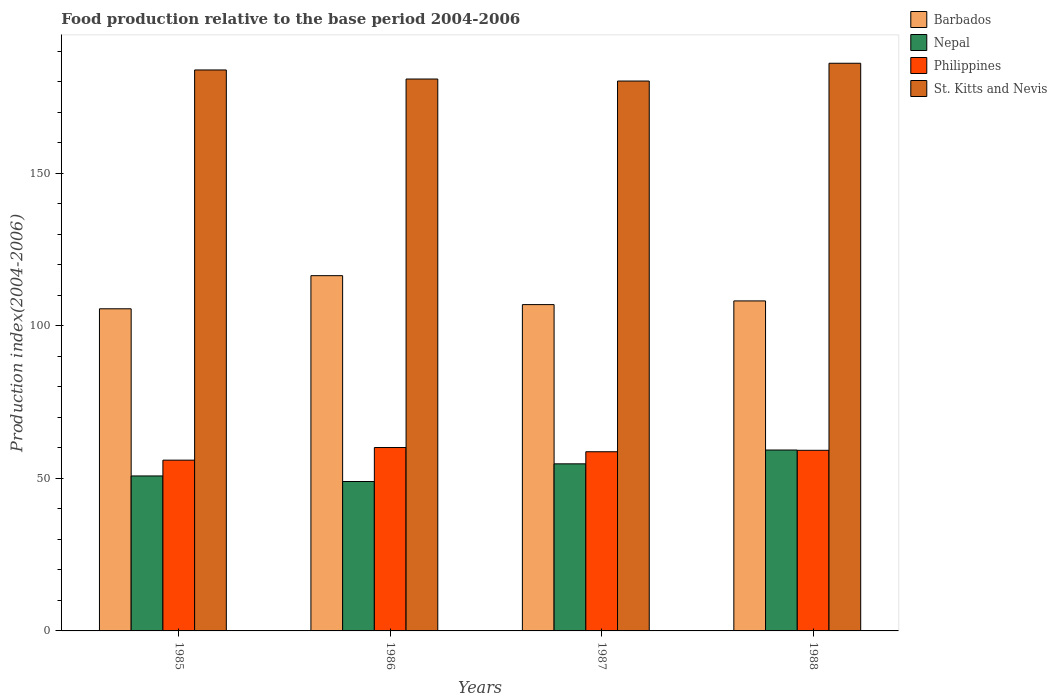How many groups of bars are there?
Provide a short and direct response. 4. Are the number of bars on each tick of the X-axis equal?
Ensure brevity in your answer.  Yes. How many bars are there on the 2nd tick from the right?
Your answer should be very brief. 4. What is the label of the 3rd group of bars from the left?
Your response must be concise. 1987. What is the food production index in Philippines in 1985?
Your response must be concise. 55.99. Across all years, what is the maximum food production index in Philippines?
Keep it short and to the point. 60.13. Across all years, what is the minimum food production index in St. Kitts and Nevis?
Your response must be concise. 180.29. In which year was the food production index in St. Kitts and Nevis maximum?
Offer a terse response. 1988. In which year was the food production index in Barbados minimum?
Ensure brevity in your answer.  1985. What is the total food production index in Philippines in the graph?
Give a very brief answer. 234.09. What is the difference between the food production index in Philippines in 1985 and that in 1987?
Give a very brief answer. -2.76. What is the difference between the food production index in Philippines in 1986 and the food production index in Barbados in 1987?
Your response must be concise. -46.86. What is the average food production index in Nepal per year?
Offer a very short reply. 53.47. In the year 1986, what is the difference between the food production index in Philippines and food production index in Nepal?
Provide a short and direct response. 11.14. What is the ratio of the food production index in St. Kitts and Nevis in 1986 to that in 1988?
Your answer should be very brief. 0.97. What is the difference between the highest and the second highest food production index in Barbados?
Offer a very short reply. 8.28. What is the difference between the highest and the lowest food production index in Barbados?
Ensure brevity in your answer.  10.86. Is the sum of the food production index in Philippines in 1985 and 1986 greater than the maximum food production index in Barbados across all years?
Ensure brevity in your answer.  No. What does the 2nd bar from the left in 1985 represents?
Your answer should be very brief. Nepal. What does the 3rd bar from the right in 1985 represents?
Provide a succinct answer. Nepal. Is it the case that in every year, the sum of the food production index in Nepal and food production index in St. Kitts and Nevis is greater than the food production index in Philippines?
Keep it short and to the point. Yes. Are all the bars in the graph horizontal?
Your response must be concise. No. How many years are there in the graph?
Offer a terse response. 4. What is the difference between two consecutive major ticks on the Y-axis?
Your answer should be compact. 50. Are the values on the major ticks of Y-axis written in scientific E-notation?
Your response must be concise. No. Does the graph contain grids?
Your answer should be compact. No. Where does the legend appear in the graph?
Give a very brief answer. Top right. How many legend labels are there?
Your answer should be very brief. 4. What is the title of the graph?
Provide a succinct answer. Food production relative to the base period 2004-2006. What is the label or title of the Y-axis?
Make the answer very short. Production index(2004-2006). What is the Production index(2004-2006) of Barbados in 1985?
Keep it short and to the point. 105.62. What is the Production index(2004-2006) in Nepal in 1985?
Your response must be concise. 50.81. What is the Production index(2004-2006) in Philippines in 1985?
Make the answer very short. 55.99. What is the Production index(2004-2006) of St. Kitts and Nevis in 1985?
Your answer should be compact. 183.92. What is the Production index(2004-2006) of Barbados in 1986?
Your response must be concise. 116.48. What is the Production index(2004-2006) in Nepal in 1986?
Make the answer very short. 48.99. What is the Production index(2004-2006) of Philippines in 1986?
Your response must be concise. 60.13. What is the Production index(2004-2006) in St. Kitts and Nevis in 1986?
Offer a very short reply. 180.95. What is the Production index(2004-2006) of Barbados in 1987?
Your answer should be very brief. 106.99. What is the Production index(2004-2006) of Nepal in 1987?
Your answer should be compact. 54.78. What is the Production index(2004-2006) of Philippines in 1987?
Make the answer very short. 58.75. What is the Production index(2004-2006) in St. Kitts and Nevis in 1987?
Keep it short and to the point. 180.29. What is the Production index(2004-2006) of Barbados in 1988?
Make the answer very short. 108.2. What is the Production index(2004-2006) of Nepal in 1988?
Offer a very short reply. 59.31. What is the Production index(2004-2006) of Philippines in 1988?
Your response must be concise. 59.22. What is the Production index(2004-2006) in St. Kitts and Nevis in 1988?
Offer a very short reply. 186.12. Across all years, what is the maximum Production index(2004-2006) of Barbados?
Ensure brevity in your answer.  116.48. Across all years, what is the maximum Production index(2004-2006) of Nepal?
Provide a succinct answer. 59.31. Across all years, what is the maximum Production index(2004-2006) in Philippines?
Offer a very short reply. 60.13. Across all years, what is the maximum Production index(2004-2006) in St. Kitts and Nevis?
Your answer should be very brief. 186.12. Across all years, what is the minimum Production index(2004-2006) in Barbados?
Offer a very short reply. 105.62. Across all years, what is the minimum Production index(2004-2006) of Nepal?
Ensure brevity in your answer.  48.99. Across all years, what is the minimum Production index(2004-2006) in Philippines?
Make the answer very short. 55.99. Across all years, what is the minimum Production index(2004-2006) in St. Kitts and Nevis?
Make the answer very short. 180.29. What is the total Production index(2004-2006) in Barbados in the graph?
Ensure brevity in your answer.  437.29. What is the total Production index(2004-2006) in Nepal in the graph?
Provide a succinct answer. 213.89. What is the total Production index(2004-2006) in Philippines in the graph?
Offer a terse response. 234.09. What is the total Production index(2004-2006) in St. Kitts and Nevis in the graph?
Your answer should be very brief. 731.28. What is the difference between the Production index(2004-2006) of Barbados in 1985 and that in 1986?
Offer a terse response. -10.86. What is the difference between the Production index(2004-2006) of Nepal in 1985 and that in 1986?
Offer a terse response. 1.82. What is the difference between the Production index(2004-2006) in Philippines in 1985 and that in 1986?
Offer a terse response. -4.14. What is the difference between the Production index(2004-2006) of St. Kitts and Nevis in 1985 and that in 1986?
Offer a very short reply. 2.97. What is the difference between the Production index(2004-2006) in Barbados in 1985 and that in 1987?
Give a very brief answer. -1.37. What is the difference between the Production index(2004-2006) of Nepal in 1985 and that in 1987?
Offer a very short reply. -3.97. What is the difference between the Production index(2004-2006) of Philippines in 1985 and that in 1987?
Make the answer very short. -2.76. What is the difference between the Production index(2004-2006) of St. Kitts and Nevis in 1985 and that in 1987?
Your answer should be very brief. 3.63. What is the difference between the Production index(2004-2006) in Barbados in 1985 and that in 1988?
Give a very brief answer. -2.58. What is the difference between the Production index(2004-2006) in Philippines in 1985 and that in 1988?
Your answer should be compact. -3.23. What is the difference between the Production index(2004-2006) of St. Kitts and Nevis in 1985 and that in 1988?
Make the answer very short. -2.2. What is the difference between the Production index(2004-2006) in Barbados in 1986 and that in 1987?
Your response must be concise. 9.49. What is the difference between the Production index(2004-2006) of Nepal in 1986 and that in 1987?
Offer a terse response. -5.79. What is the difference between the Production index(2004-2006) in Philippines in 1986 and that in 1987?
Provide a succinct answer. 1.38. What is the difference between the Production index(2004-2006) of St. Kitts and Nevis in 1986 and that in 1987?
Your answer should be very brief. 0.66. What is the difference between the Production index(2004-2006) in Barbados in 1986 and that in 1988?
Offer a terse response. 8.28. What is the difference between the Production index(2004-2006) of Nepal in 1986 and that in 1988?
Your answer should be very brief. -10.32. What is the difference between the Production index(2004-2006) in Philippines in 1986 and that in 1988?
Offer a very short reply. 0.91. What is the difference between the Production index(2004-2006) of St. Kitts and Nevis in 1986 and that in 1988?
Offer a very short reply. -5.17. What is the difference between the Production index(2004-2006) in Barbados in 1987 and that in 1988?
Offer a very short reply. -1.21. What is the difference between the Production index(2004-2006) in Nepal in 1987 and that in 1988?
Make the answer very short. -4.53. What is the difference between the Production index(2004-2006) in Philippines in 1987 and that in 1988?
Offer a very short reply. -0.47. What is the difference between the Production index(2004-2006) in St. Kitts and Nevis in 1987 and that in 1988?
Your response must be concise. -5.83. What is the difference between the Production index(2004-2006) in Barbados in 1985 and the Production index(2004-2006) in Nepal in 1986?
Keep it short and to the point. 56.63. What is the difference between the Production index(2004-2006) in Barbados in 1985 and the Production index(2004-2006) in Philippines in 1986?
Offer a very short reply. 45.49. What is the difference between the Production index(2004-2006) of Barbados in 1985 and the Production index(2004-2006) of St. Kitts and Nevis in 1986?
Ensure brevity in your answer.  -75.33. What is the difference between the Production index(2004-2006) of Nepal in 1985 and the Production index(2004-2006) of Philippines in 1986?
Your answer should be compact. -9.32. What is the difference between the Production index(2004-2006) in Nepal in 1985 and the Production index(2004-2006) in St. Kitts and Nevis in 1986?
Your answer should be very brief. -130.14. What is the difference between the Production index(2004-2006) in Philippines in 1985 and the Production index(2004-2006) in St. Kitts and Nevis in 1986?
Keep it short and to the point. -124.96. What is the difference between the Production index(2004-2006) of Barbados in 1985 and the Production index(2004-2006) of Nepal in 1987?
Provide a short and direct response. 50.84. What is the difference between the Production index(2004-2006) of Barbados in 1985 and the Production index(2004-2006) of Philippines in 1987?
Your answer should be compact. 46.87. What is the difference between the Production index(2004-2006) in Barbados in 1985 and the Production index(2004-2006) in St. Kitts and Nevis in 1987?
Keep it short and to the point. -74.67. What is the difference between the Production index(2004-2006) in Nepal in 1985 and the Production index(2004-2006) in Philippines in 1987?
Make the answer very short. -7.94. What is the difference between the Production index(2004-2006) in Nepal in 1985 and the Production index(2004-2006) in St. Kitts and Nevis in 1987?
Your answer should be compact. -129.48. What is the difference between the Production index(2004-2006) in Philippines in 1985 and the Production index(2004-2006) in St. Kitts and Nevis in 1987?
Your answer should be very brief. -124.3. What is the difference between the Production index(2004-2006) of Barbados in 1985 and the Production index(2004-2006) of Nepal in 1988?
Offer a very short reply. 46.31. What is the difference between the Production index(2004-2006) of Barbados in 1985 and the Production index(2004-2006) of Philippines in 1988?
Offer a very short reply. 46.4. What is the difference between the Production index(2004-2006) of Barbados in 1985 and the Production index(2004-2006) of St. Kitts and Nevis in 1988?
Your answer should be very brief. -80.5. What is the difference between the Production index(2004-2006) in Nepal in 1985 and the Production index(2004-2006) in Philippines in 1988?
Offer a terse response. -8.41. What is the difference between the Production index(2004-2006) in Nepal in 1985 and the Production index(2004-2006) in St. Kitts and Nevis in 1988?
Ensure brevity in your answer.  -135.31. What is the difference between the Production index(2004-2006) of Philippines in 1985 and the Production index(2004-2006) of St. Kitts and Nevis in 1988?
Your answer should be very brief. -130.13. What is the difference between the Production index(2004-2006) of Barbados in 1986 and the Production index(2004-2006) of Nepal in 1987?
Offer a very short reply. 61.7. What is the difference between the Production index(2004-2006) of Barbados in 1986 and the Production index(2004-2006) of Philippines in 1987?
Your answer should be very brief. 57.73. What is the difference between the Production index(2004-2006) in Barbados in 1986 and the Production index(2004-2006) in St. Kitts and Nevis in 1987?
Your response must be concise. -63.81. What is the difference between the Production index(2004-2006) in Nepal in 1986 and the Production index(2004-2006) in Philippines in 1987?
Keep it short and to the point. -9.76. What is the difference between the Production index(2004-2006) in Nepal in 1986 and the Production index(2004-2006) in St. Kitts and Nevis in 1987?
Offer a very short reply. -131.3. What is the difference between the Production index(2004-2006) of Philippines in 1986 and the Production index(2004-2006) of St. Kitts and Nevis in 1987?
Your response must be concise. -120.16. What is the difference between the Production index(2004-2006) of Barbados in 1986 and the Production index(2004-2006) of Nepal in 1988?
Ensure brevity in your answer.  57.17. What is the difference between the Production index(2004-2006) in Barbados in 1986 and the Production index(2004-2006) in Philippines in 1988?
Offer a very short reply. 57.26. What is the difference between the Production index(2004-2006) of Barbados in 1986 and the Production index(2004-2006) of St. Kitts and Nevis in 1988?
Offer a terse response. -69.64. What is the difference between the Production index(2004-2006) in Nepal in 1986 and the Production index(2004-2006) in Philippines in 1988?
Offer a terse response. -10.23. What is the difference between the Production index(2004-2006) in Nepal in 1986 and the Production index(2004-2006) in St. Kitts and Nevis in 1988?
Provide a succinct answer. -137.13. What is the difference between the Production index(2004-2006) in Philippines in 1986 and the Production index(2004-2006) in St. Kitts and Nevis in 1988?
Ensure brevity in your answer.  -125.99. What is the difference between the Production index(2004-2006) of Barbados in 1987 and the Production index(2004-2006) of Nepal in 1988?
Your response must be concise. 47.68. What is the difference between the Production index(2004-2006) in Barbados in 1987 and the Production index(2004-2006) in Philippines in 1988?
Offer a terse response. 47.77. What is the difference between the Production index(2004-2006) of Barbados in 1987 and the Production index(2004-2006) of St. Kitts and Nevis in 1988?
Keep it short and to the point. -79.13. What is the difference between the Production index(2004-2006) in Nepal in 1987 and the Production index(2004-2006) in Philippines in 1988?
Your answer should be compact. -4.44. What is the difference between the Production index(2004-2006) in Nepal in 1987 and the Production index(2004-2006) in St. Kitts and Nevis in 1988?
Give a very brief answer. -131.34. What is the difference between the Production index(2004-2006) in Philippines in 1987 and the Production index(2004-2006) in St. Kitts and Nevis in 1988?
Your response must be concise. -127.37. What is the average Production index(2004-2006) of Barbados per year?
Give a very brief answer. 109.32. What is the average Production index(2004-2006) in Nepal per year?
Make the answer very short. 53.47. What is the average Production index(2004-2006) in Philippines per year?
Provide a succinct answer. 58.52. What is the average Production index(2004-2006) of St. Kitts and Nevis per year?
Ensure brevity in your answer.  182.82. In the year 1985, what is the difference between the Production index(2004-2006) of Barbados and Production index(2004-2006) of Nepal?
Ensure brevity in your answer.  54.81. In the year 1985, what is the difference between the Production index(2004-2006) in Barbados and Production index(2004-2006) in Philippines?
Offer a very short reply. 49.63. In the year 1985, what is the difference between the Production index(2004-2006) of Barbados and Production index(2004-2006) of St. Kitts and Nevis?
Provide a short and direct response. -78.3. In the year 1985, what is the difference between the Production index(2004-2006) of Nepal and Production index(2004-2006) of Philippines?
Your answer should be very brief. -5.18. In the year 1985, what is the difference between the Production index(2004-2006) in Nepal and Production index(2004-2006) in St. Kitts and Nevis?
Keep it short and to the point. -133.11. In the year 1985, what is the difference between the Production index(2004-2006) of Philippines and Production index(2004-2006) of St. Kitts and Nevis?
Ensure brevity in your answer.  -127.93. In the year 1986, what is the difference between the Production index(2004-2006) in Barbados and Production index(2004-2006) in Nepal?
Your answer should be very brief. 67.49. In the year 1986, what is the difference between the Production index(2004-2006) of Barbados and Production index(2004-2006) of Philippines?
Your answer should be compact. 56.35. In the year 1986, what is the difference between the Production index(2004-2006) of Barbados and Production index(2004-2006) of St. Kitts and Nevis?
Offer a very short reply. -64.47. In the year 1986, what is the difference between the Production index(2004-2006) of Nepal and Production index(2004-2006) of Philippines?
Make the answer very short. -11.14. In the year 1986, what is the difference between the Production index(2004-2006) of Nepal and Production index(2004-2006) of St. Kitts and Nevis?
Provide a short and direct response. -131.96. In the year 1986, what is the difference between the Production index(2004-2006) of Philippines and Production index(2004-2006) of St. Kitts and Nevis?
Provide a succinct answer. -120.82. In the year 1987, what is the difference between the Production index(2004-2006) in Barbados and Production index(2004-2006) in Nepal?
Ensure brevity in your answer.  52.21. In the year 1987, what is the difference between the Production index(2004-2006) of Barbados and Production index(2004-2006) of Philippines?
Make the answer very short. 48.24. In the year 1987, what is the difference between the Production index(2004-2006) in Barbados and Production index(2004-2006) in St. Kitts and Nevis?
Offer a very short reply. -73.3. In the year 1987, what is the difference between the Production index(2004-2006) in Nepal and Production index(2004-2006) in Philippines?
Your answer should be compact. -3.97. In the year 1987, what is the difference between the Production index(2004-2006) of Nepal and Production index(2004-2006) of St. Kitts and Nevis?
Provide a succinct answer. -125.51. In the year 1987, what is the difference between the Production index(2004-2006) in Philippines and Production index(2004-2006) in St. Kitts and Nevis?
Your answer should be compact. -121.54. In the year 1988, what is the difference between the Production index(2004-2006) of Barbados and Production index(2004-2006) of Nepal?
Your response must be concise. 48.89. In the year 1988, what is the difference between the Production index(2004-2006) in Barbados and Production index(2004-2006) in Philippines?
Provide a short and direct response. 48.98. In the year 1988, what is the difference between the Production index(2004-2006) in Barbados and Production index(2004-2006) in St. Kitts and Nevis?
Your answer should be very brief. -77.92. In the year 1988, what is the difference between the Production index(2004-2006) in Nepal and Production index(2004-2006) in Philippines?
Offer a very short reply. 0.09. In the year 1988, what is the difference between the Production index(2004-2006) in Nepal and Production index(2004-2006) in St. Kitts and Nevis?
Offer a terse response. -126.81. In the year 1988, what is the difference between the Production index(2004-2006) of Philippines and Production index(2004-2006) of St. Kitts and Nevis?
Your response must be concise. -126.9. What is the ratio of the Production index(2004-2006) of Barbados in 1985 to that in 1986?
Make the answer very short. 0.91. What is the ratio of the Production index(2004-2006) in Nepal in 1985 to that in 1986?
Provide a short and direct response. 1.04. What is the ratio of the Production index(2004-2006) in Philippines in 1985 to that in 1986?
Keep it short and to the point. 0.93. What is the ratio of the Production index(2004-2006) in St. Kitts and Nevis in 1985 to that in 1986?
Your answer should be very brief. 1.02. What is the ratio of the Production index(2004-2006) of Barbados in 1985 to that in 1987?
Provide a short and direct response. 0.99. What is the ratio of the Production index(2004-2006) of Nepal in 1985 to that in 1987?
Offer a very short reply. 0.93. What is the ratio of the Production index(2004-2006) in Philippines in 1985 to that in 1987?
Ensure brevity in your answer.  0.95. What is the ratio of the Production index(2004-2006) in St. Kitts and Nevis in 1985 to that in 1987?
Ensure brevity in your answer.  1.02. What is the ratio of the Production index(2004-2006) in Barbados in 1985 to that in 1988?
Provide a succinct answer. 0.98. What is the ratio of the Production index(2004-2006) in Nepal in 1985 to that in 1988?
Make the answer very short. 0.86. What is the ratio of the Production index(2004-2006) of Philippines in 1985 to that in 1988?
Keep it short and to the point. 0.95. What is the ratio of the Production index(2004-2006) of St. Kitts and Nevis in 1985 to that in 1988?
Make the answer very short. 0.99. What is the ratio of the Production index(2004-2006) of Barbados in 1986 to that in 1987?
Offer a very short reply. 1.09. What is the ratio of the Production index(2004-2006) of Nepal in 1986 to that in 1987?
Provide a short and direct response. 0.89. What is the ratio of the Production index(2004-2006) of Philippines in 1986 to that in 1987?
Ensure brevity in your answer.  1.02. What is the ratio of the Production index(2004-2006) of Barbados in 1986 to that in 1988?
Your response must be concise. 1.08. What is the ratio of the Production index(2004-2006) in Nepal in 1986 to that in 1988?
Your answer should be compact. 0.83. What is the ratio of the Production index(2004-2006) in Philippines in 1986 to that in 1988?
Provide a short and direct response. 1.02. What is the ratio of the Production index(2004-2006) of St. Kitts and Nevis in 1986 to that in 1988?
Your answer should be very brief. 0.97. What is the ratio of the Production index(2004-2006) in Barbados in 1987 to that in 1988?
Ensure brevity in your answer.  0.99. What is the ratio of the Production index(2004-2006) in Nepal in 1987 to that in 1988?
Offer a terse response. 0.92. What is the ratio of the Production index(2004-2006) in St. Kitts and Nevis in 1987 to that in 1988?
Give a very brief answer. 0.97. What is the difference between the highest and the second highest Production index(2004-2006) of Barbados?
Provide a succinct answer. 8.28. What is the difference between the highest and the second highest Production index(2004-2006) in Nepal?
Your answer should be very brief. 4.53. What is the difference between the highest and the second highest Production index(2004-2006) of Philippines?
Your response must be concise. 0.91. What is the difference between the highest and the second highest Production index(2004-2006) in St. Kitts and Nevis?
Provide a succinct answer. 2.2. What is the difference between the highest and the lowest Production index(2004-2006) in Barbados?
Provide a succinct answer. 10.86. What is the difference between the highest and the lowest Production index(2004-2006) of Nepal?
Give a very brief answer. 10.32. What is the difference between the highest and the lowest Production index(2004-2006) of Philippines?
Keep it short and to the point. 4.14. What is the difference between the highest and the lowest Production index(2004-2006) in St. Kitts and Nevis?
Provide a short and direct response. 5.83. 